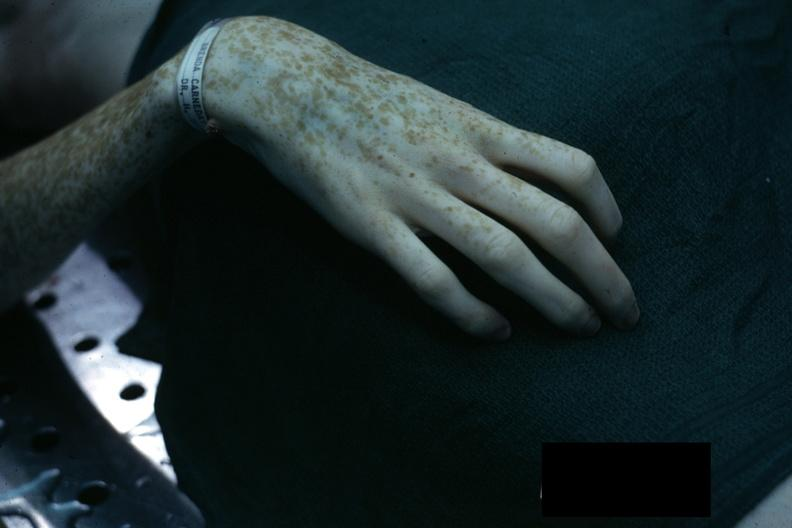re extremities present?
Answer the question using a single word or phrase. Yes 